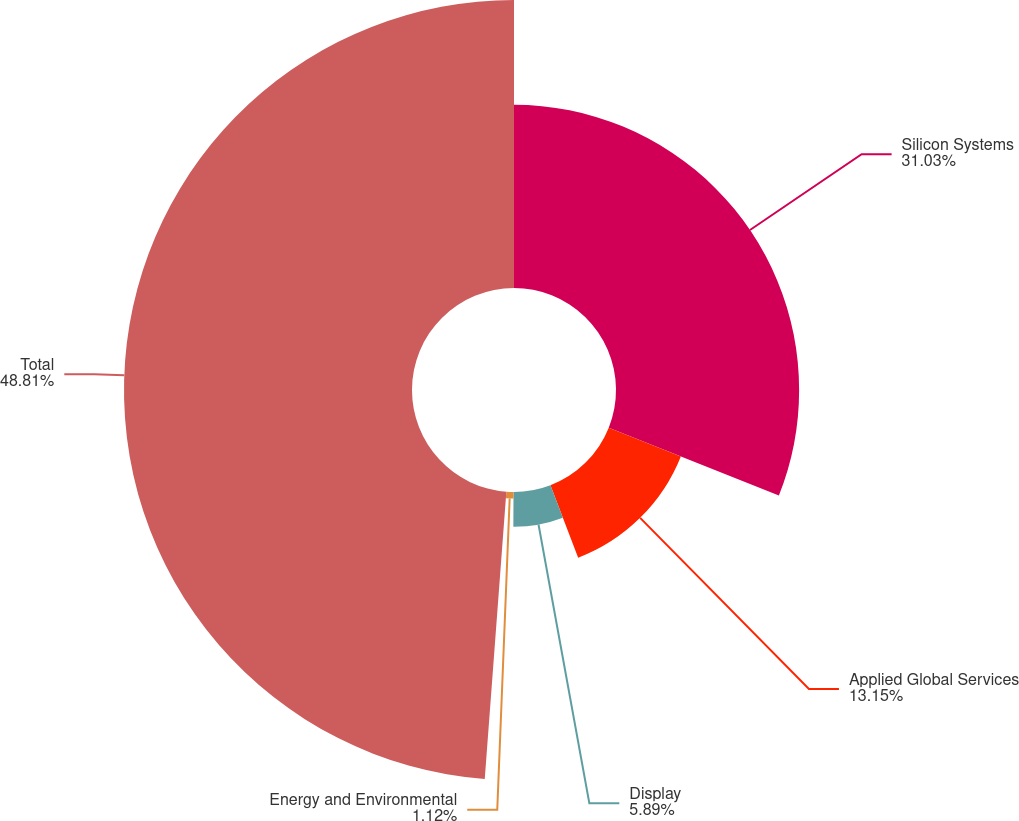<chart> <loc_0><loc_0><loc_500><loc_500><pie_chart><fcel>Silicon Systems<fcel>Applied Global Services<fcel>Display<fcel>Energy and Environmental<fcel>Total<nl><fcel>31.03%<fcel>13.15%<fcel>5.89%<fcel>1.12%<fcel>48.8%<nl></chart> 